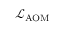Convert formula to latex. <formula><loc_0><loc_0><loc_500><loc_500>\mathcal { L } _ { A O M }</formula> 